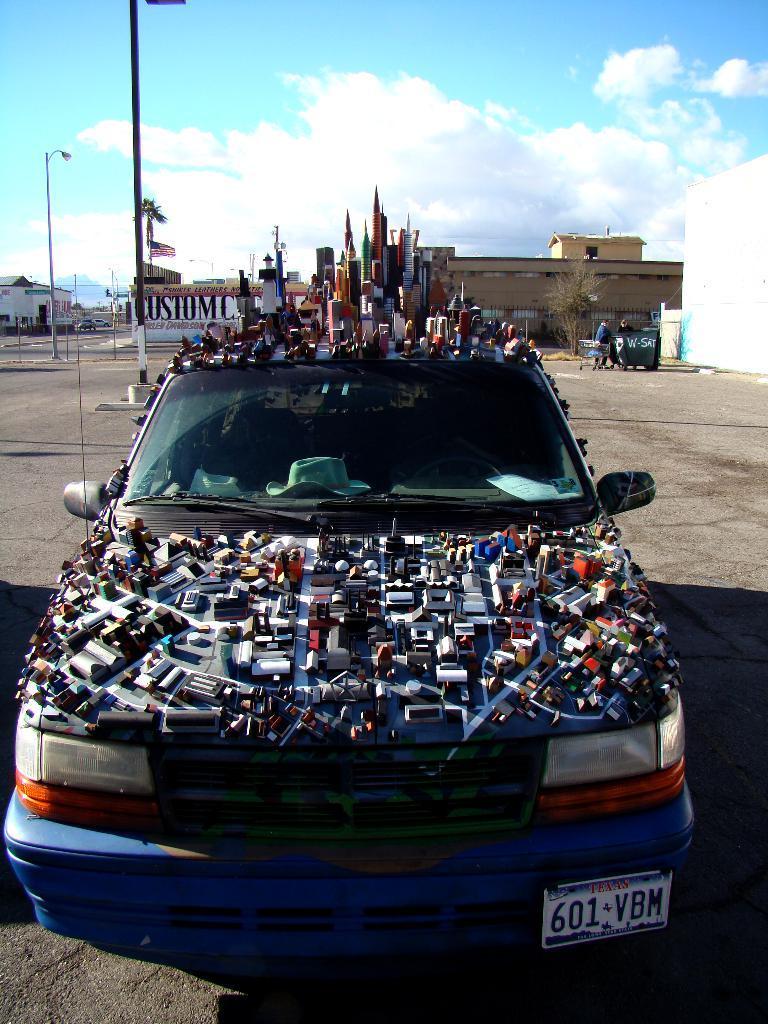Please provide a concise description of this image. In this picture we can see a car in the front, in the background there is a building, we can see a tree here, on the left side there is a pole and a light, we can see the sky at the top of the picture, there is a person standing here, we can see some things present on the car. 